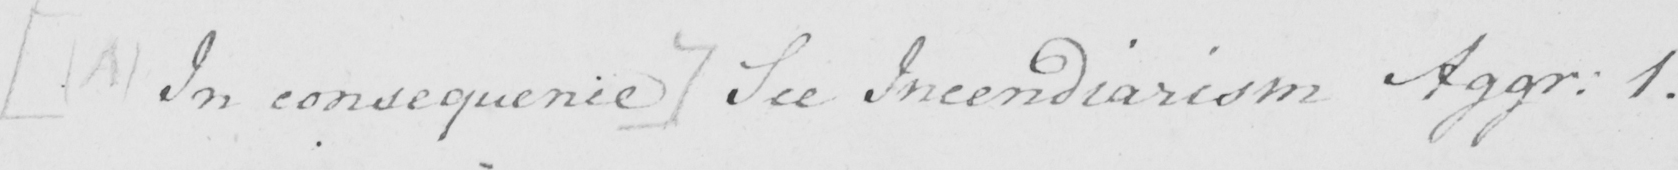What text is written in this handwritten line? [  ( A )  In consequence ]  See Incendiarism Aggr :  1 . 